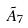Convert formula to latex. <formula><loc_0><loc_0><loc_500><loc_500>\tilde { A } _ { 7 }</formula> 